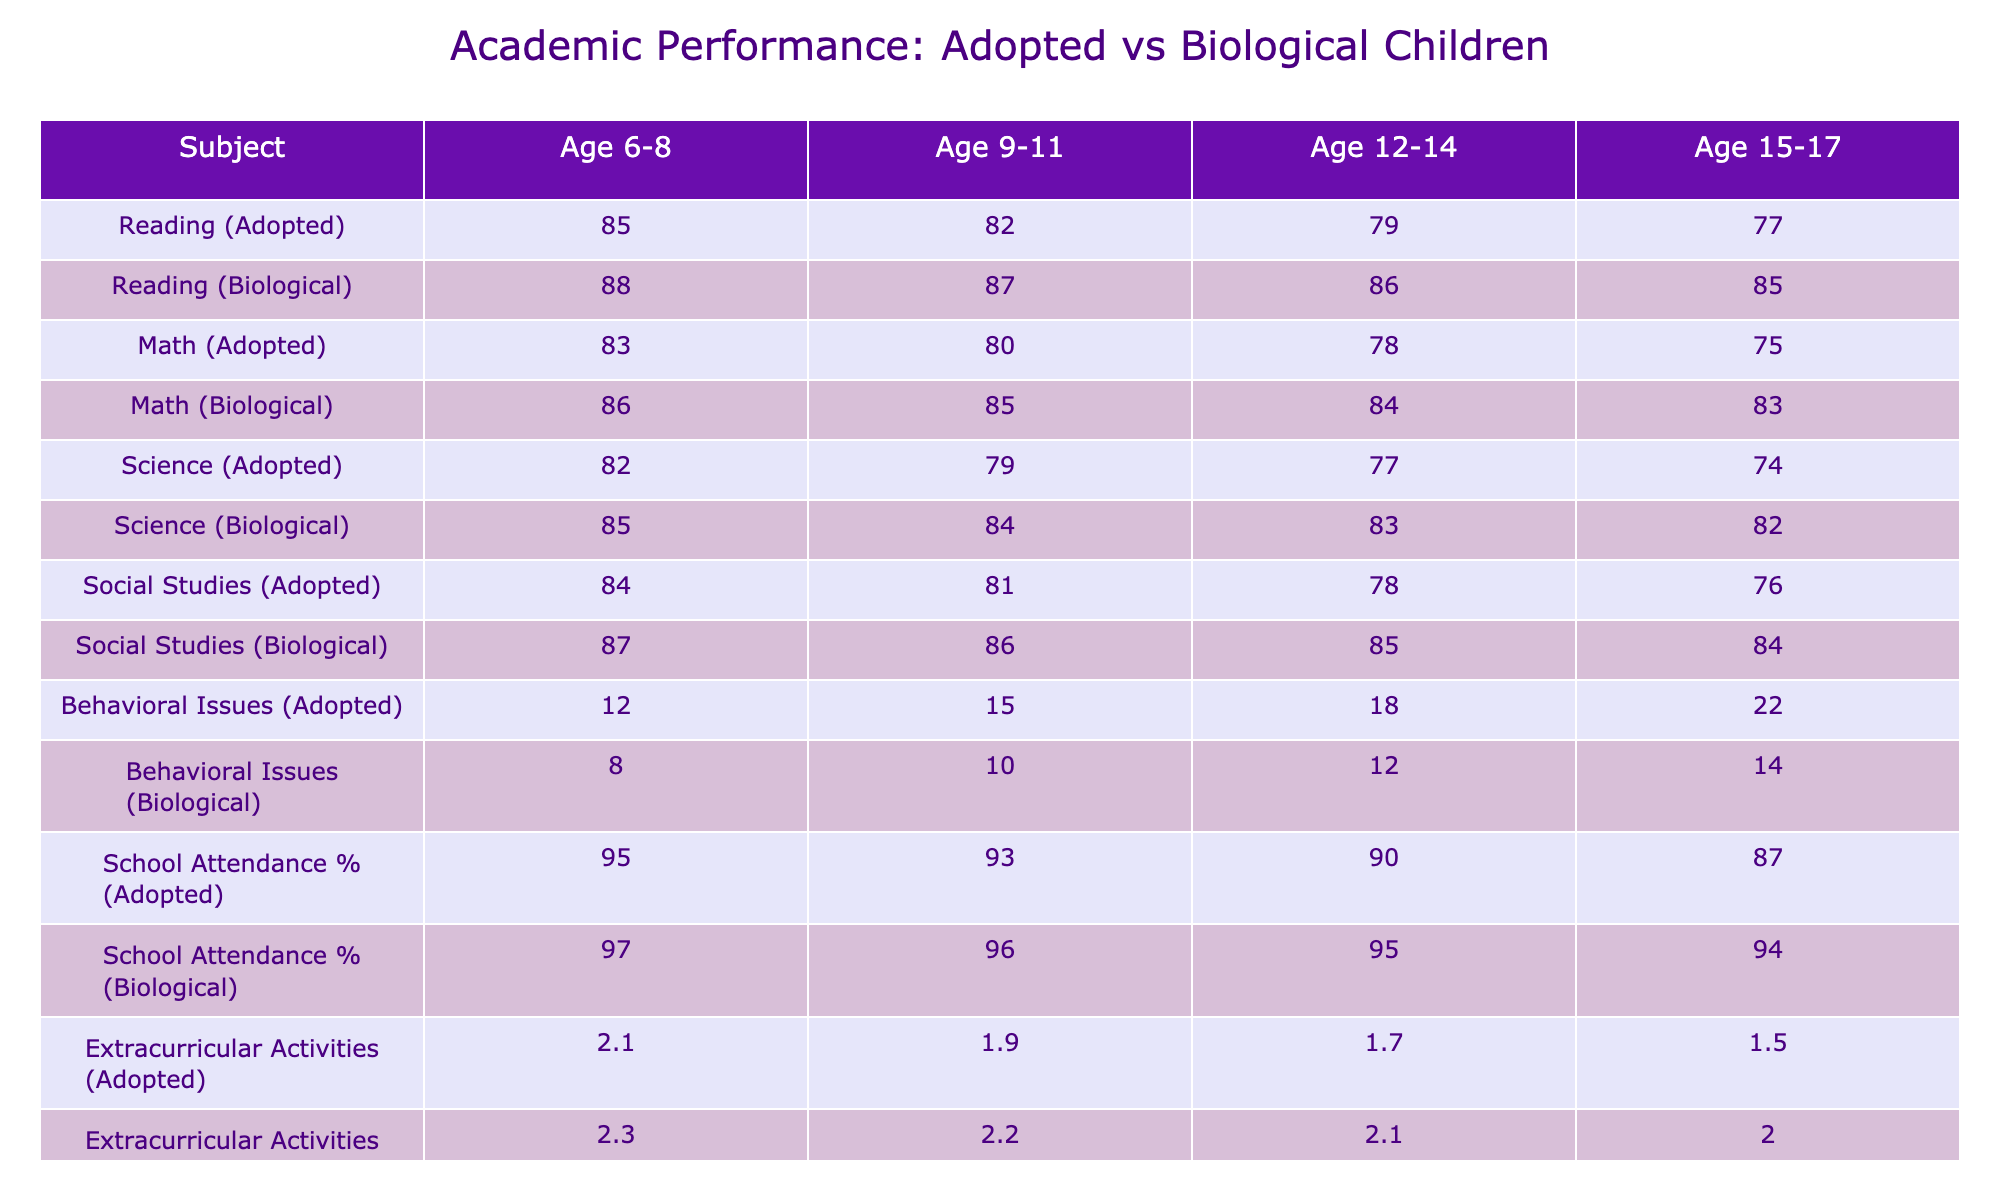What is the reading score for biological children aged 12-14? Referring to the table, the reading score for biological children in the 12-14 age group is noted, which is 86.
Answer: 86 What is the math score difference between adopted and biological children aged 15-17? The math score for adopted children aged 15-17 is 75 and for biological children is 83. Subtracting these gives 83 - 75 = 8.
Answer: 8 How does the school attendance percentage for adopted children change from age 6-8 to age 15-17? The school attendance percentage for adopted children in age 6-8 is 95% and in age 15-17 is 87%. The change is 95 - 87 = 8%.
Answer: 8% What is the average science score for adopted children across all age groups? The science scores for adopted children are 82, 79, 77, and 74. Adding these gives 312, and dividing by 4 gives an average of 78.
Answer: 78 Are behavioral issues reported for adopted children higher than those for biological children at age 9-11? The table shows that adopted children have 15 behavioral issues while biological children have 10. Therefore, yes, adopted children are reported to have more issues.
Answer: Yes Which subject shows the largest decline in scores for adopted children from ages 6-8 to 15-17? Reviewing the scores, Reading declines from 85 to 77 (8 points), Math from 83 to 75 (8 points), Science from 82 to 74 (8 points), and Social Studies from 84 to 76 (8 points). All subjects have the same decline but we compare which overall performance is lowest now. Reading is the lowest final score.
Answer: Reading Do adopted children score higher in extracurricular activities compared to biological children at age 9-11? The table shows adopted children with 1.9 activities and biological children with 2.2. Thus, adopted children score lower.
Answer: No How much higher is the average reading score for biological children compared to adopted children aged 12-14? The reading score for biological children aged 12-14 is 86 and for adopted children is 79. The difference is 86 - 79 = 7.
Answer: 7 What pattern can be observed in the behavioral issues for both adopted and biological children as they age? The table indicates an increase in behavioral issues for adopted children (12 to 22) and a smaller increase for biological children (8 to 14). The pattern shows that adopted children have consistently higher issues and they are increasing more significantly.
Answer: Increasing for both; adopted children have more 